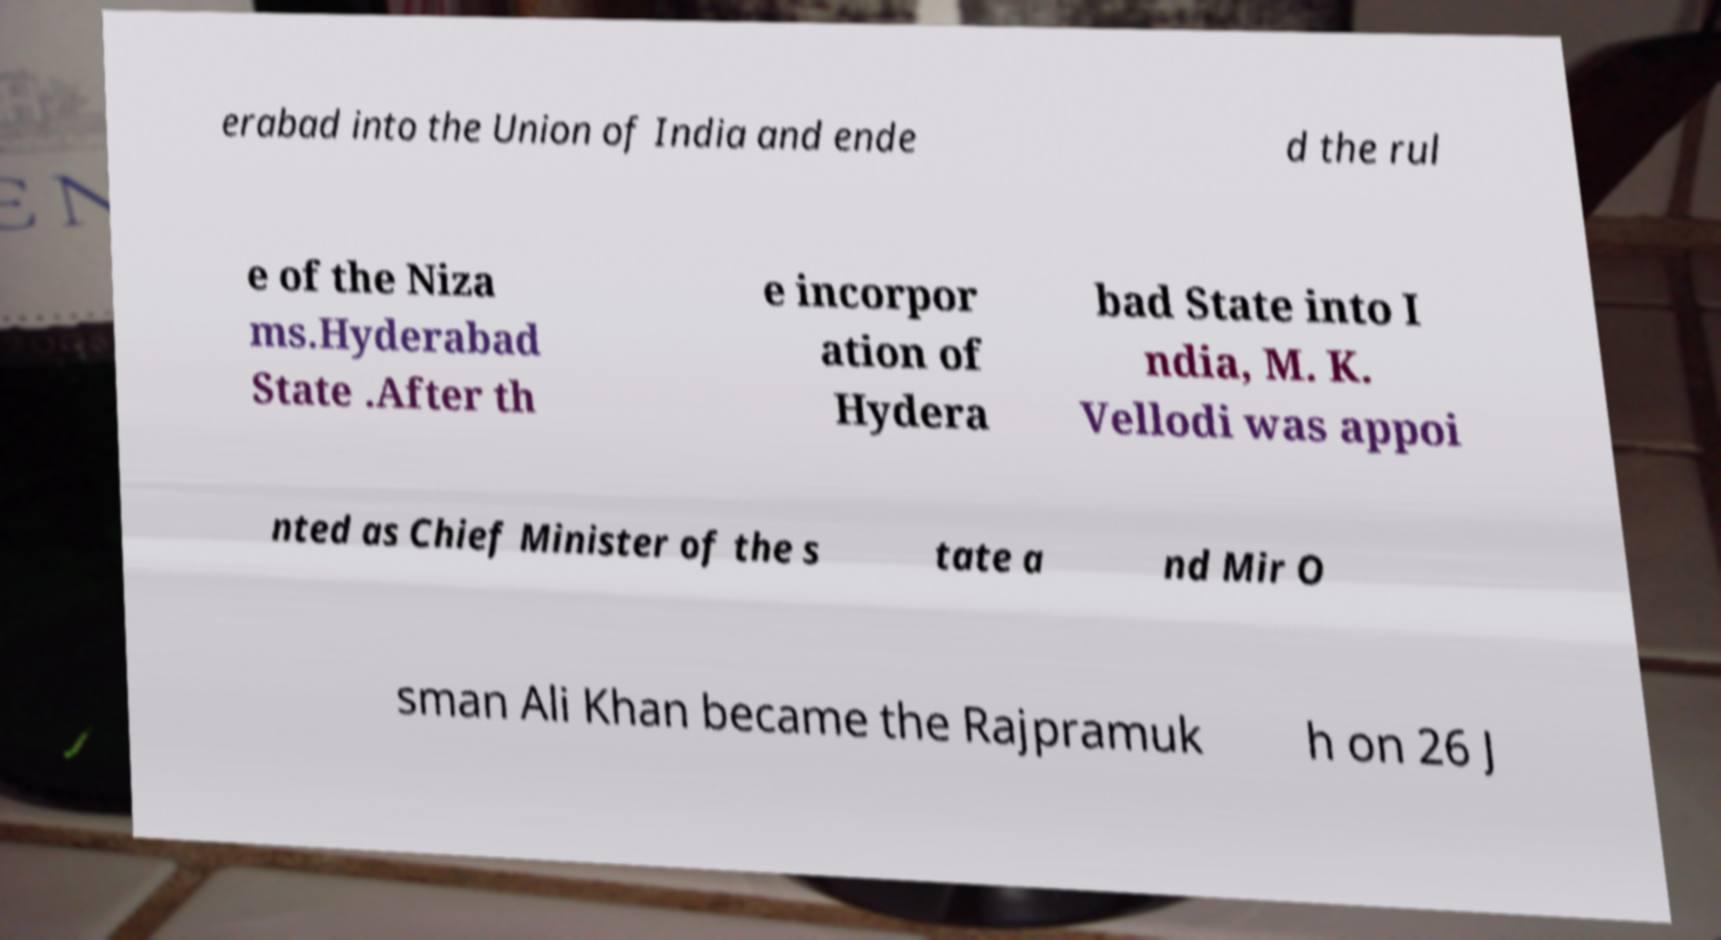Can you accurately transcribe the text from the provided image for me? erabad into the Union of India and ende d the rul e of the Niza ms.Hyderabad State .After th e incorpor ation of Hydera bad State into I ndia, M. K. Vellodi was appoi nted as Chief Minister of the s tate a nd Mir O sman Ali Khan became the Rajpramuk h on 26 J 